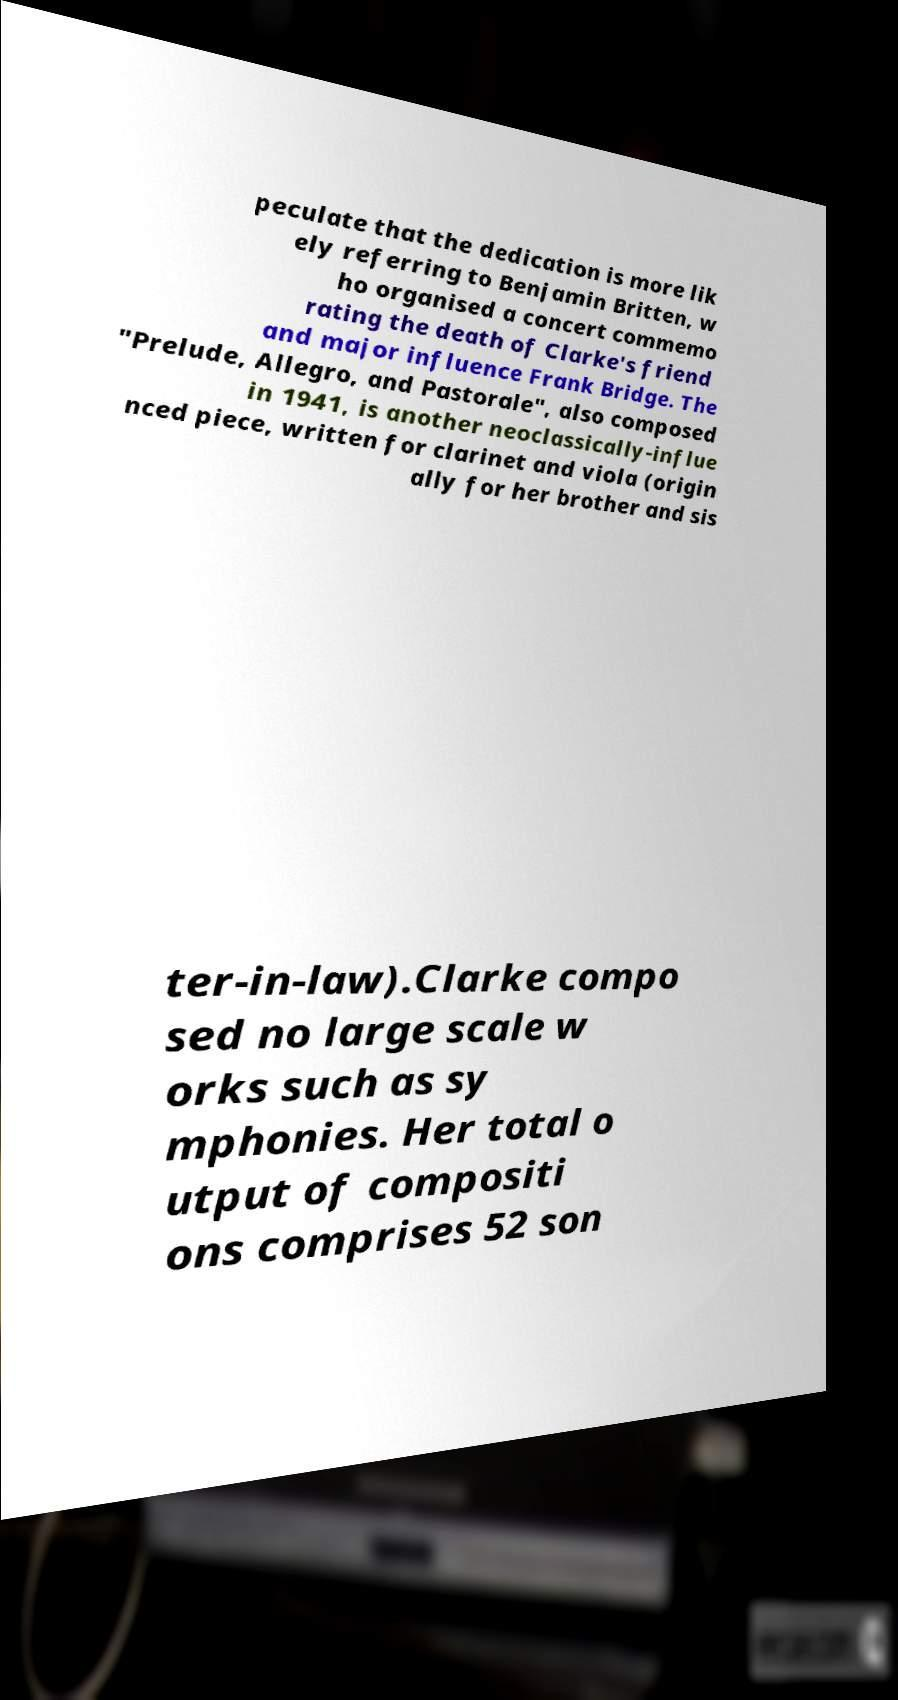Can you accurately transcribe the text from the provided image for me? peculate that the dedication is more lik ely referring to Benjamin Britten, w ho organised a concert commemo rating the death of Clarke's friend and major influence Frank Bridge. The "Prelude, Allegro, and Pastorale", also composed in 1941, is another neoclassically-influe nced piece, written for clarinet and viola (origin ally for her brother and sis ter-in-law).Clarke compo sed no large scale w orks such as sy mphonies. Her total o utput of compositi ons comprises 52 son 